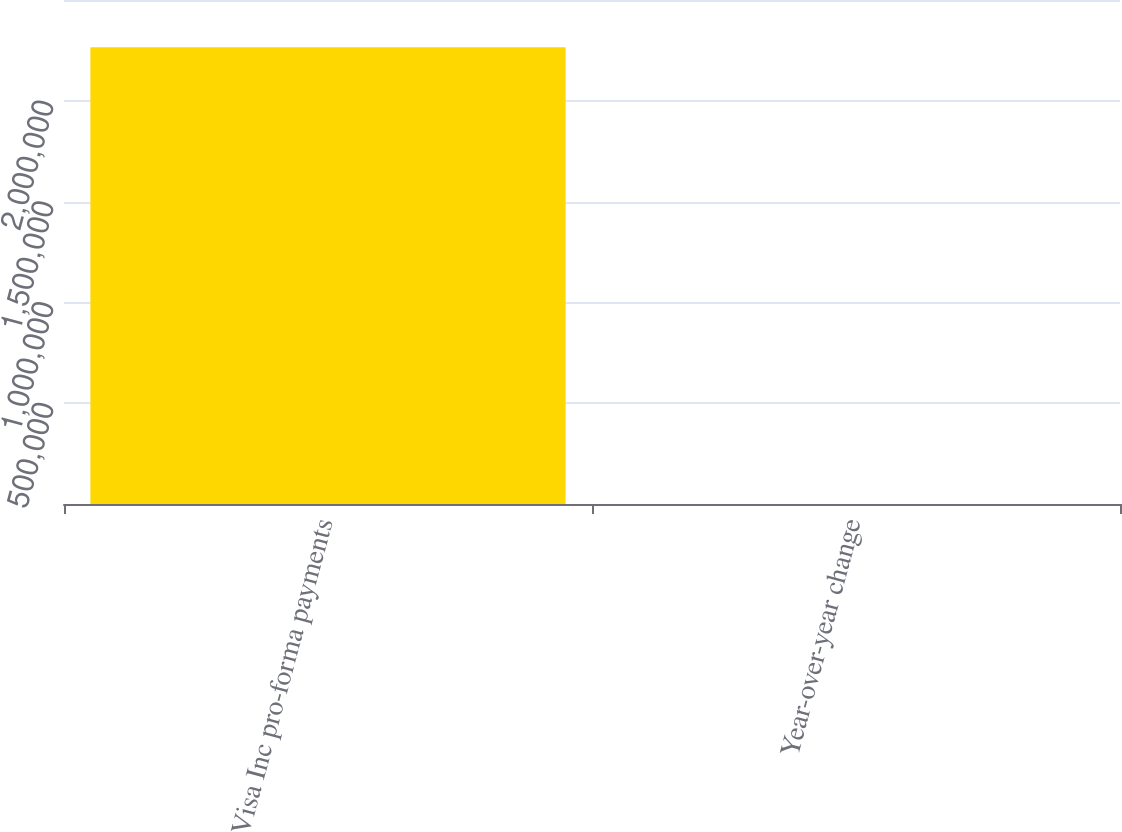<chart> <loc_0><loc_0><loc_500><loc_500><bar_chart><fcel>Visa Inc pro-forma payments<fcel>Year-over-year change<nl><fcel>2.26594e+06<fcel>13<nl></chart> 